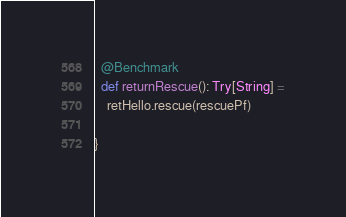<code> <loc_0><loc_0><loc_500><loc_500><_Scala_>  @Benchmark
  def returnRescue(): Try[String] =
    retHello.rescue(rescuePf)

}
</code> 